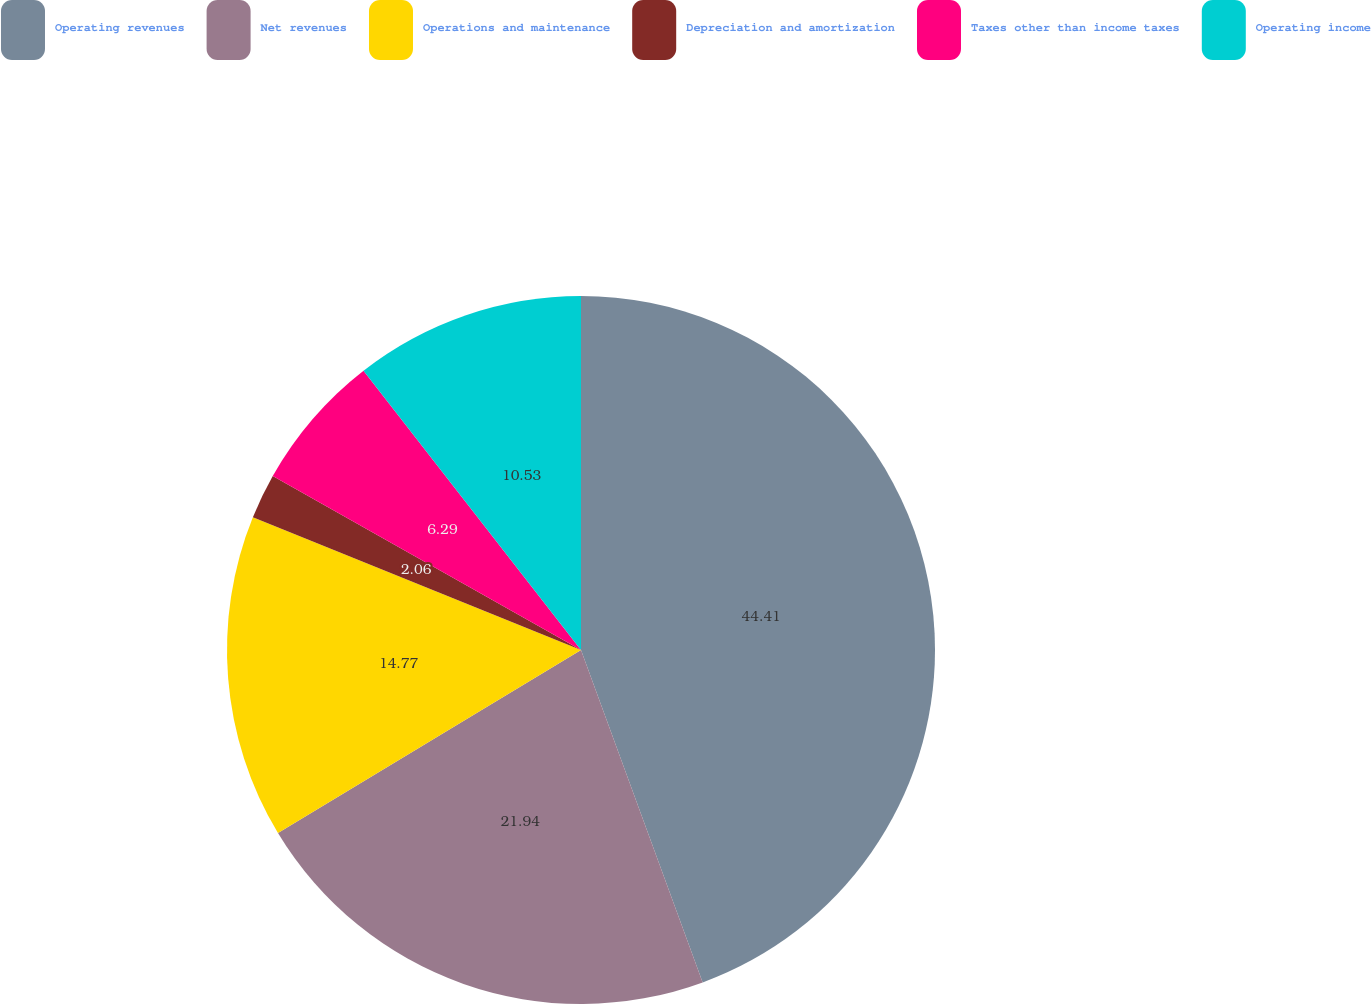Convert chart to OTSL. <chart><loc_0><loc_0><loc_500><loc_500><pie_chart><fcel>Operating revenues<fcel>Net revenues<fcel>Operations and maintenance<fcel>Depreciation and amortization<fcel>Taxes other than income taxes<fcel>Operating income<nl><fcel>44.42%<fcel>21.94%<fcel>14.77%<fcel>2.06%<fcel>6.29%<fcel>10.53%<nl></chart> 